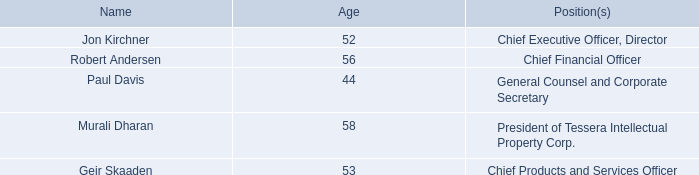Information About Our Executive Officers
Set forth below are the name, age and position of each of our executive officers
The following are biographical summaries of our executive officers other than Mr. Kirchner, for whom a biographical summary is set forth under “Information about Our Board of Directors.”
Robert Andersen is executive vice president and chief financial officer of Xperi Corporation. He became executive vice president and chief financial officer of Xperi Corporation in January 2014. Prior to joining Xperi Corporation, he served as executive vice president and CFO of G2 Holdings Corp. d/b/a Components Direct. Mr. Andersen previously served as CFO at Phoenix Technologies Ltd. and held senior financial roles at Wind River Systems, Inc. and NextOffice, Inc. His finance career began at Hewlett-Packard Company, where he served in various controller, treasury and technology finance management roles. Mr. Andersen served on the board of directors of publicly traded Quantum Corporation through March 2017. He currently serves on the board of directors of the Alameda County Community Food Bank in the role of vice chair. Mr. Andersen holds a B.A. in economics from the University of California, Davis, and an M.B.A. from the Anderson School of Management at the University of California, Los Angeles.
Paul Davis is general counsel and corporate secretary of Xperi Corporation. He joined Xperi Corporation in August 2011, and became general counsel and corporate secretary in July 2013. Before joining Xperi Corporation, he was an attorney at Skadden, Arps, Slate, Meagher & Flom LLP, where his practice focused on mergers and acquisitions, corporate securities matters and corporate governance. Mr. Davis holds a Juris Doctor from the University of California, Hastings College of the Law and B.A. degrees in history and political science from the University of California, San Diego. While at Hastings, he was magna cum laude, an Order of the Coif member and a managing editor on the Hastings Law Journal.
Murali Dharan has served as president of Tessera Intellectual Property Corp. (“Tessera”) since October of 2017 and is responsible for the strategic direction, management and growth of the Tessera intellectual property licensing business. He has extensive leadership experience, most recently as CEO of IPVALUE, guiding the company from a start-up to an industry leader and helping partners to generate more than $1.6 billion in IP revenue. Prior to joining IPVALUE in 2002, Mr. Dharan held executive roles at various technology companies, including executive vice president at Preview Systems, vice president and general manager at Silicon Graphics, and vice president and general manager at NEC. Mr. Dharan holds an electrical engineering degree from Anna University in India, a master’s degree in computer science from Indiana University, and an MBA from Stanford University.
Geir Skaaden has served as our chief products and services officer since December 2016 and leads global sales, business development and product management for our portfolio of imaging and audio solutions. He served as DTS’s Executive Vice President, Products, Platforms and Solutions from October 2015 until its acquisition by the Company in December 2016, having previously served as DTS’s Senior Vice President, Corporate Business Development, Digital Content and Media Solutions since December 2013. Prior to that, Mr. Skaaden served as DTS’s Senior Vice President, Products & Platforms from April 2012 to December 2013. From 2008 to 2012, Mr. Skaaden served in a number of positions overseeing numerous aspects including strategic sales, licensing operations, and business development. Prior to joining DTS in 2008, Mr. Skaaden served as the Chief Executive Officer at Neural Audio Corporation from 2004 to 2008, where he previously served as Vice President, Corporate Development from 2002 to 2004. Mr. Skaaden holds a B.A. in Finance from the University of Oregon, a Business degree from the Norwegian School of Management and an M.B.A. from the University of Washington.
We have adopted a written code of business conduct and ethics that applies to our principal executive officer, principal financial officer, principal accounting officer or controller, or persons serving similar functions. The text of our code of business conduct and ethics has been posted on our website at http://www.xperi.com. and is included as an exhibit to our Current Report on Form 8-K filed with the SEC on December 1, 2016.
Who is the Chief Financial Officer? Robert andersen. When did Paul Davis join Xperi Corporation? August 2011. What degrees does Geir Skaaden hold? A b.a. in finance from the university of oregon, a business degree from the norwegian school of management and an m.b.a. from the university of washington. What is the average age of the executive officers of Xperi Corporation? (52+56+44+58+53)/5 
Answer: 52.6. What is the percentage of years that Geir Skaaden served as the Chief Executive Officer of Neural Audio Corporation throughout his life?
Answer scale should be: percent. (2008-2004)/53 
Answer: 7.55. Who is the oldest among all executive officers of Xperi Corporation? 58 is the highest
Answer: murali dharan. 